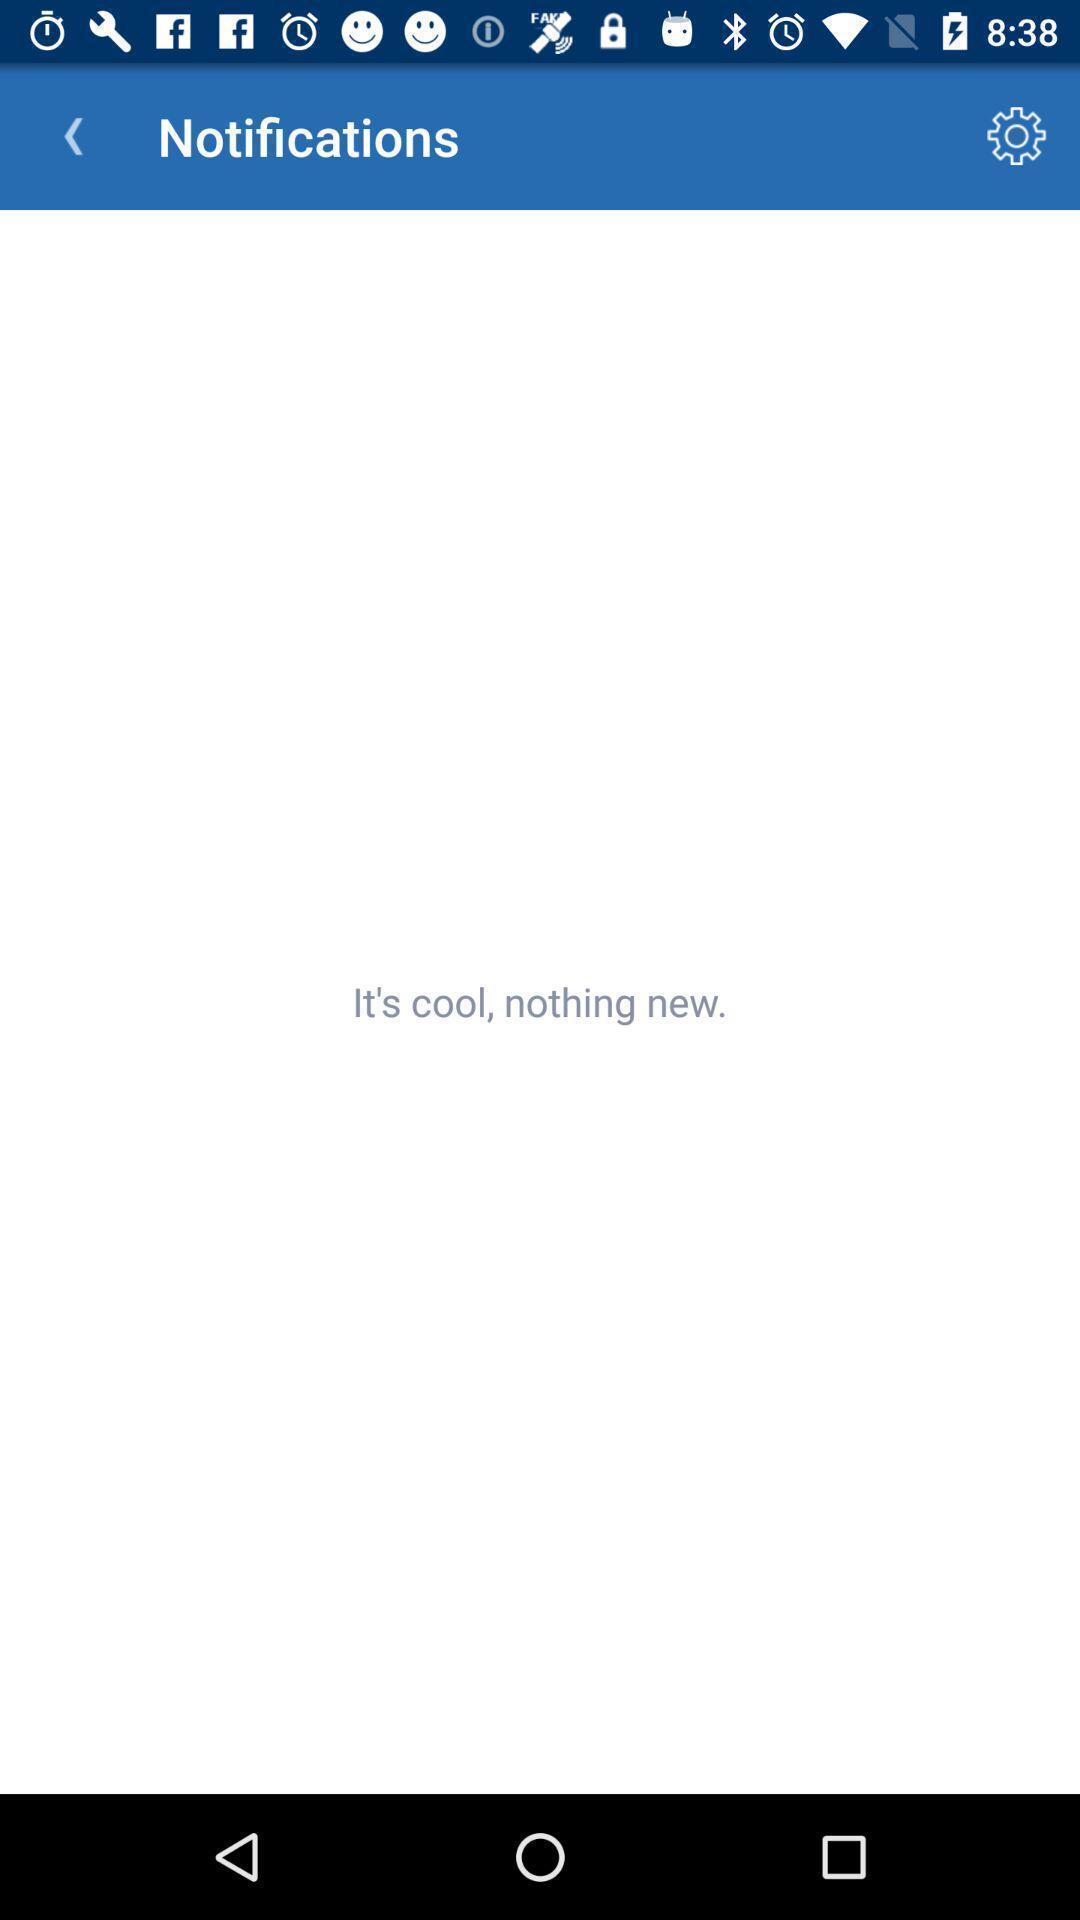Give me a narrative description of this picture. Screen displaying the notifications page. 